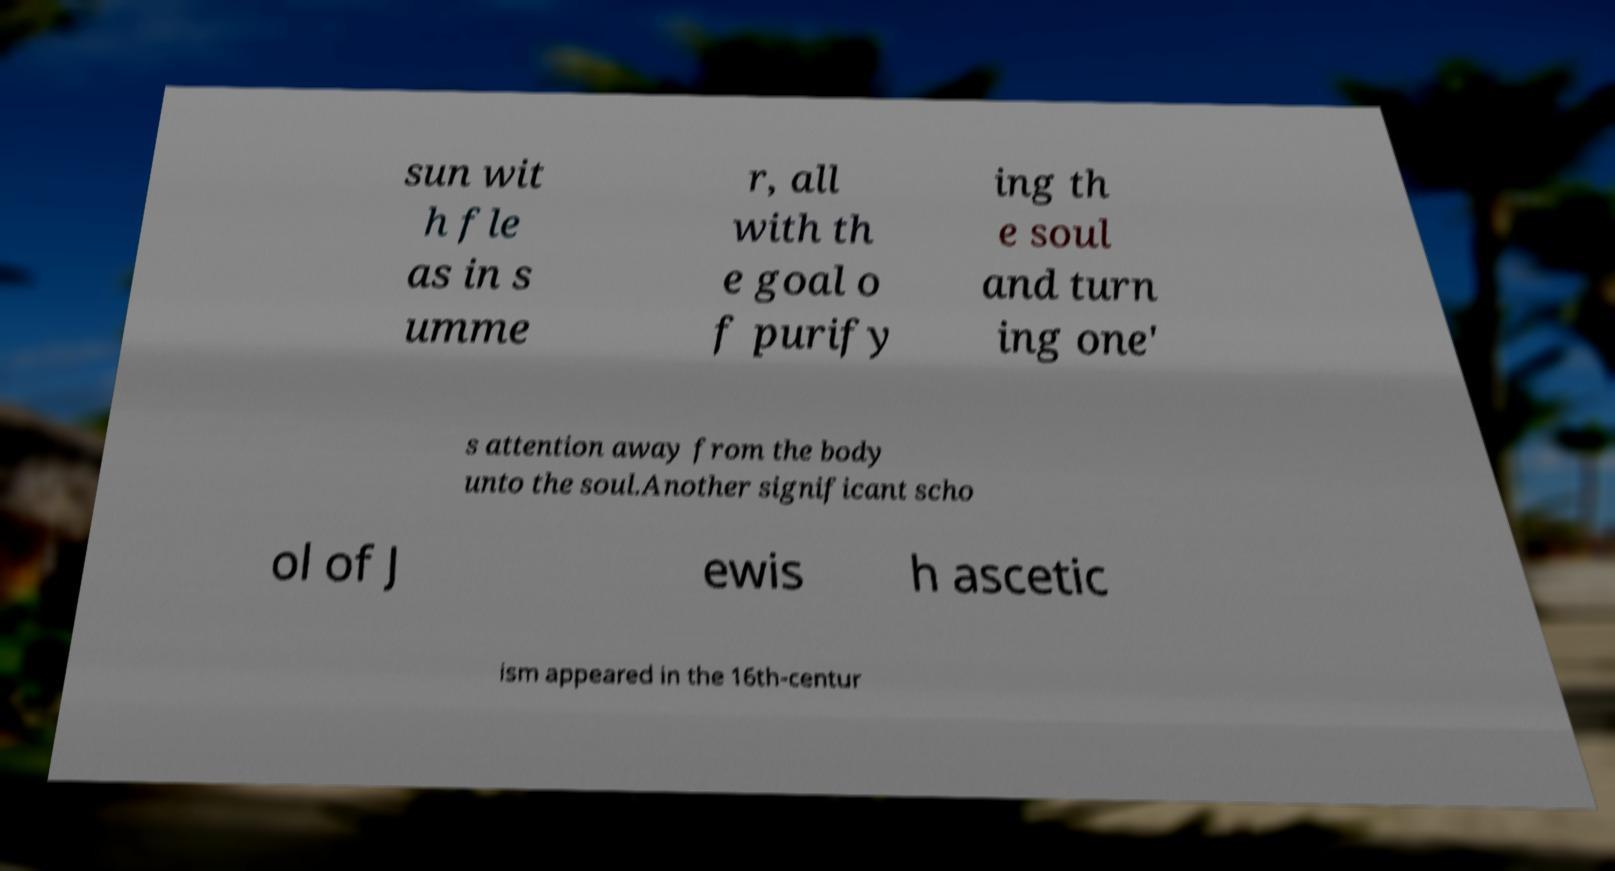Can you accurately transcribe the text from the provided image for me? sun wit h fle as in s umme r, all with th e goal o f purify ing th e soul and turn ing one' s attention away from the body unto the soul.Another significant scho ol of J ewis h ascetic ism appeared in the 16th-centur 